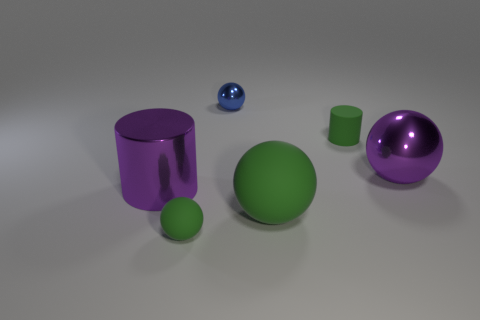Subtract 1 spheres. How many spheres are left? 3 Add 1 big metal cylinders. How many objects exist? 7 Subtract all cylinders. How many objects are left? 4 Add 6 small blue spheres. How many small blue spheres exist? 7 Subtract 0 red spheres. How many objects are left? 6 Subtract all big shiny cylinders. Subtract all blue spheres. How many objects are left? 4 Add 2 large green rubber spheres. How many large green rubber spheres are left? 3 